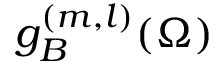<formula> <loc_0><loc_0><loc_500><loc_500>g _ { B } ^ { ( m , l ) } ( \Omega )</formula> 